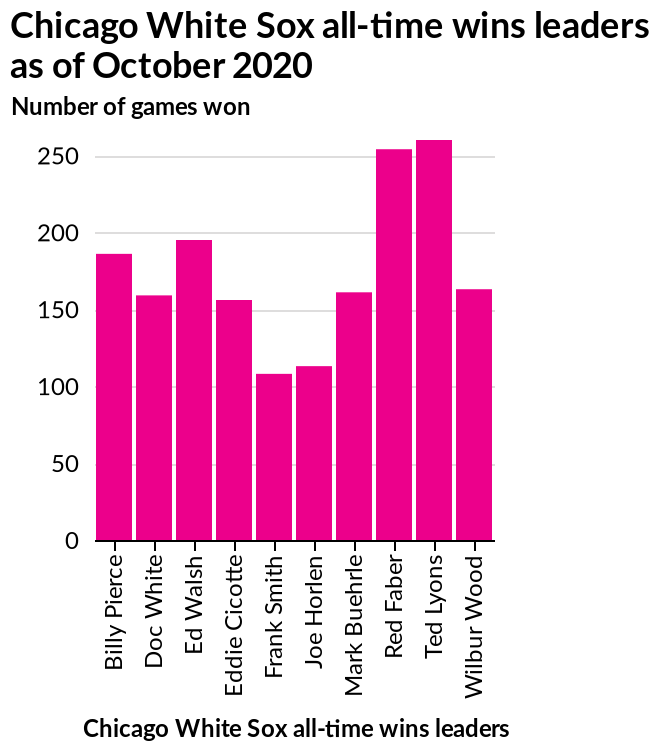<image>
Who won the most games for the Chicago White Sox?  Ted Lyons won the most games for the Chicago White Sox with over 250 wins. Who are the all-time wins leaders for the Chicago White Sox as of October 2020?  The all-time wins leaders for the Chicago White Sox as of October 2020 are Billy Pierce and Wilbur Wood. Who won the least games for the team?  Frank Smith won the least games for the team with just over 100 wins. How many wins did Red Faber have for the Chicago White Sox? Red Faber had over 250 wins for the Chicago White Sox. Did Frank Smith win the most games for the team with just under 100 wins? No. Frank Smith won the least games for the team with just over 100 wins. 